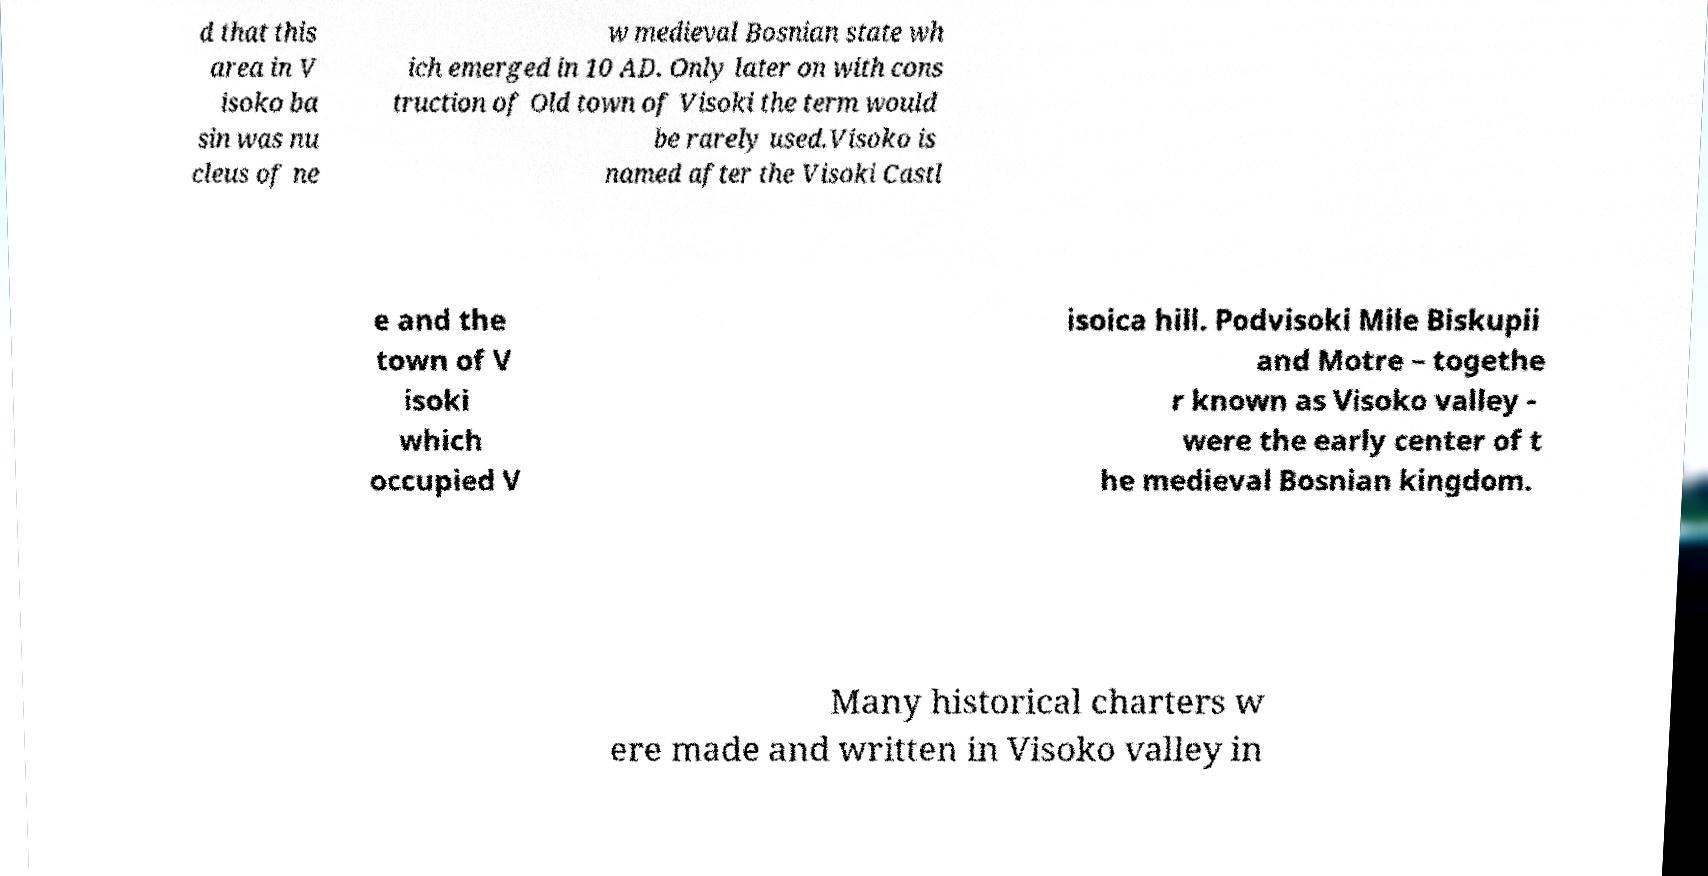Could you assist in decoding the text presented in this image and type it out clearly? d that this area in V isoko ba sin was nu cleus of ne w medieval Bosnian state wh ich emerged in 10 AD. Only later on with cons truction of Old town of Visoki the term would be rarely used.Visoko is named after the Visoki Castl e and the town of V isoki which occupied V isoica hill. Podvisoki Mile Biskupii and Motre – togethe r known as Visoko valley - were the early center of t he medieval Bosnian kingdom. Many historical charters w ere made and written in Visoko valley in 